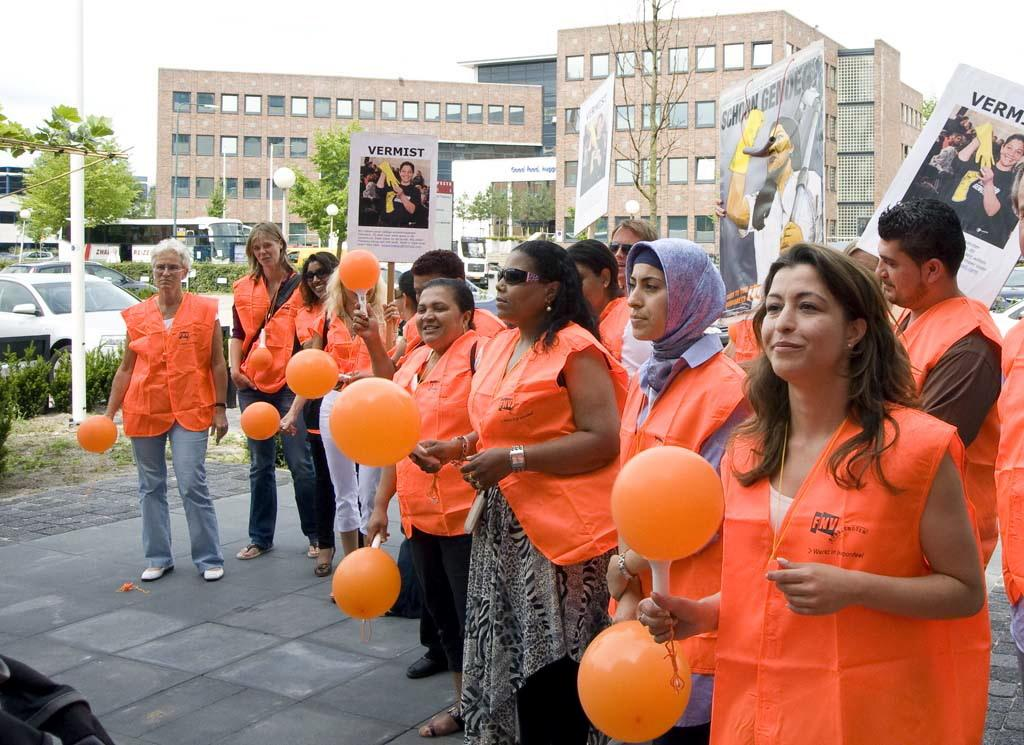What are the people in the image holding in their hands? The people in the image are holding objects in their hands. What can be seen on the walls or surfaces in the image? There are posters in the image. What is visible in the background of the image? In the background, there are poles, street lights, vehicles, trees, and buildings. What type of pancake is being flipped by the person in the image? There is no pancake present in the image, and no one is flipping anything. 